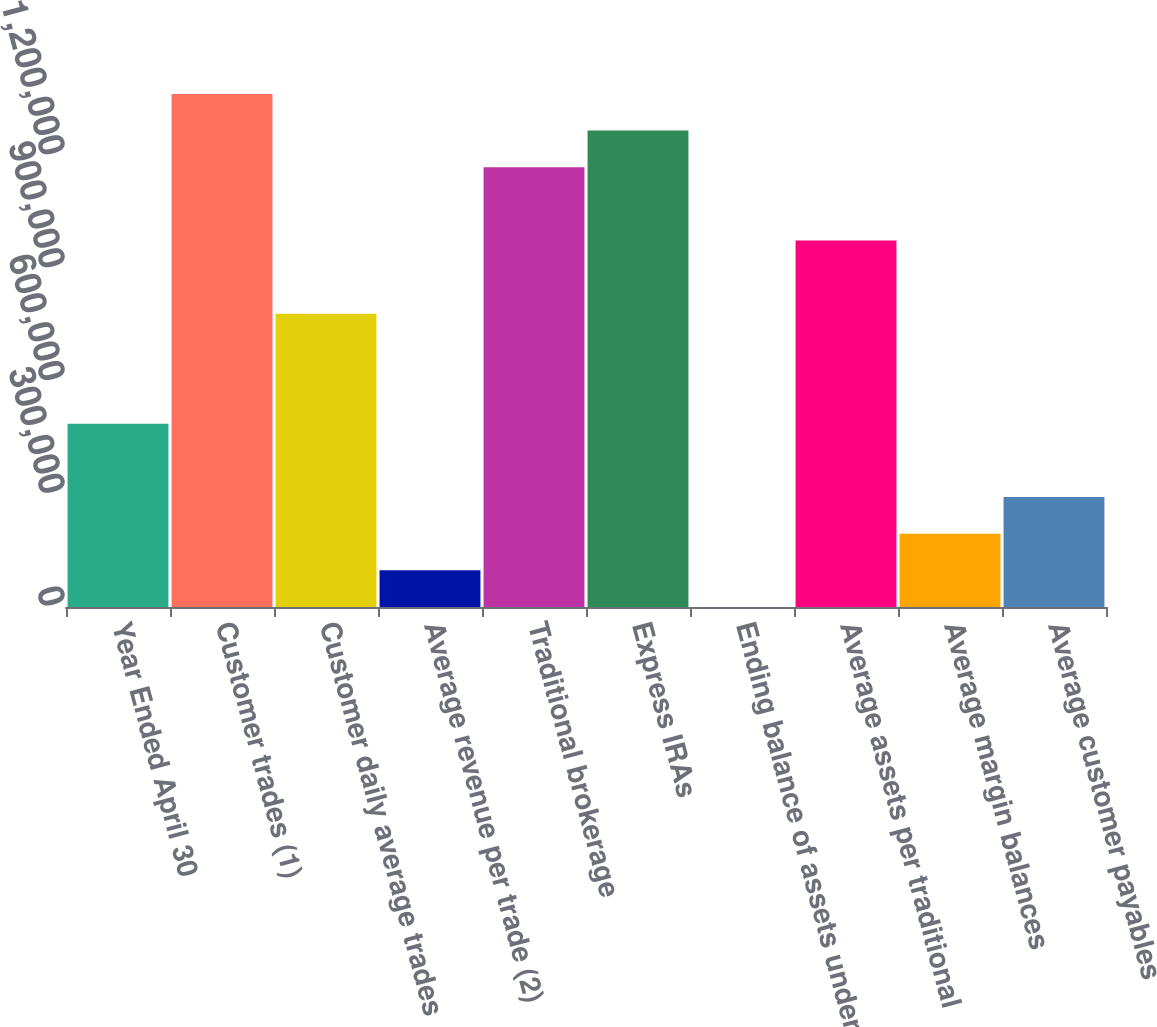Convert chart to OTSL. <chart><loc_0><loc_0><loc_500><loc_500><bar_chart><fcel>Year Ended April 30<fcel>Customer trades (1)<fcel>Customer daily average trades<fcel>Average revenue per trade (2)<fcel>Traditional brokerage<fcel>Express IRAs<fcel>Ending balance of assets under<fcel>Average assets per traditional<fcel>Average margin balances<fcel>Average customer payables<nl><fcel>487328<fcel>1.36446e+06<fcel>779706<fcel>97491.1<fcel>1.16954e+06<fcel>1.267e+06<fcel>31.8<fcel>974625<fcel>194950<fcel>292410<nl></chart> 